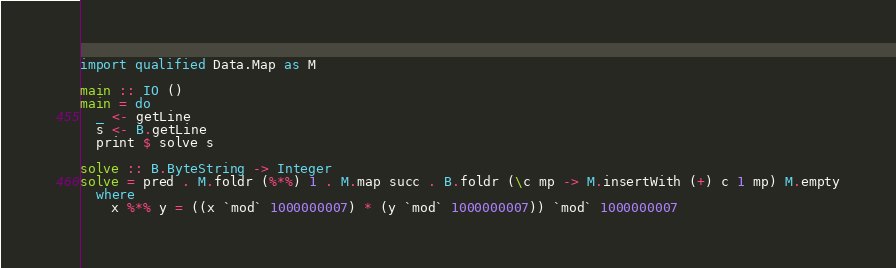<code> <loc_0><loc_0><loc_500><loc_500><_Haskell_>import qualified Data.Map as M

main :: IO ()
main = do
  _ <- getLine
  s <- B.getLine
  print $ solve s

solve :: B.ByteString -> Integer
solve = pred . M.foldr (%*%) 1 . M.map succ . B.foldr (\c mp -> M.insertWith (+) c 1 mp) M.empty
  where
    x %*% y = ((x `mod` 1000000007) * (y `mod` 1000000007)) `mod` 1000000007</code> 